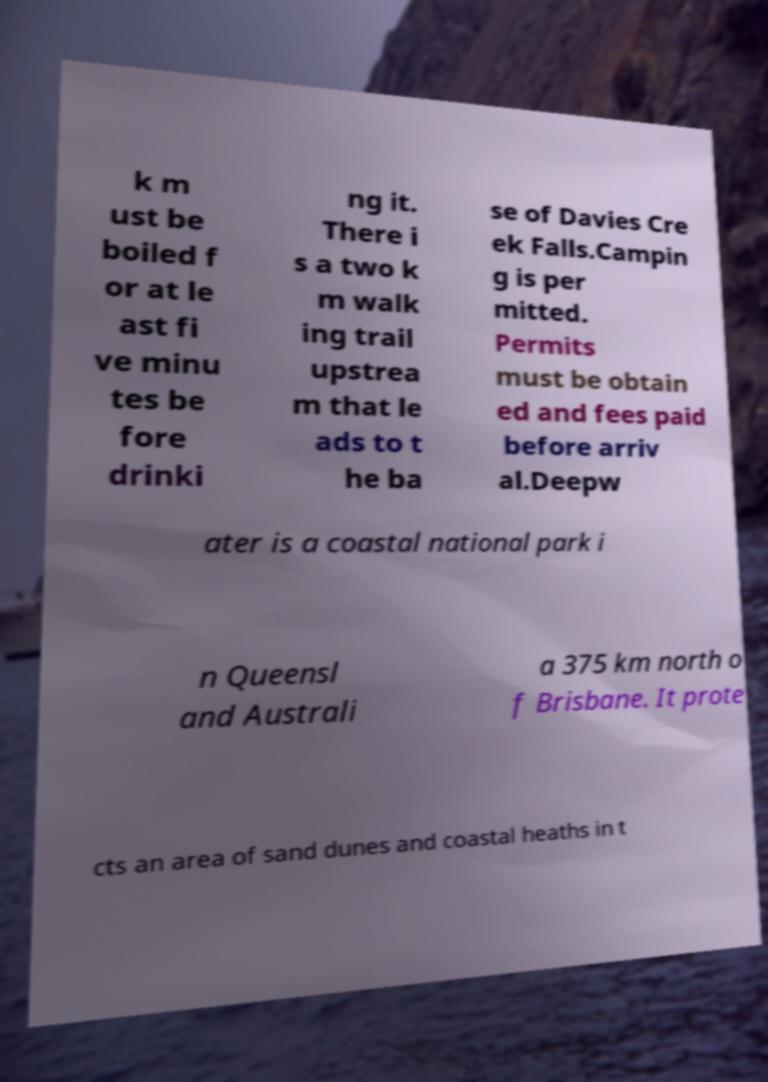Can you accurately transcribe the text from the provided image for me? k m ust be boiled f or at le ast fi ve minu tes be fore drinki ng it. There i s a two k m walk ing trail upstrea m that le ads to t he ba se of Davies Cre ek Falls.Campin g is per mitted. Permits must be obtain ed and fees paid before arriv al.Deepw ater is a coastal national park i n Queensl and Australi a 375 km north o f Brisbane. It prote cts an area of sand dunes and coastal heaths in t 